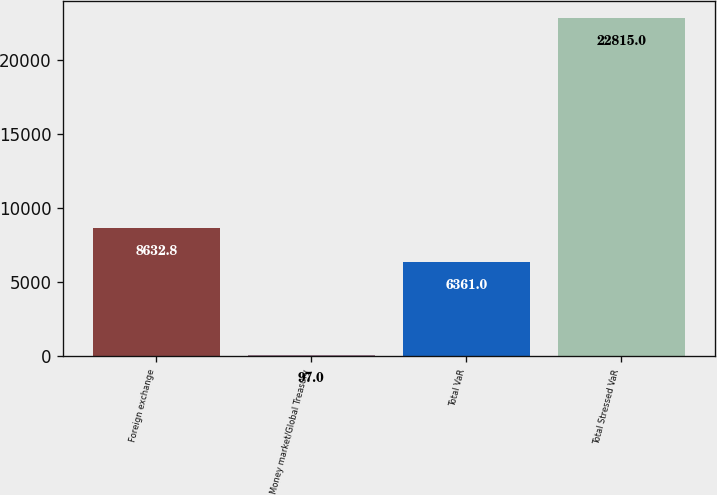Convert chart. <chart><loc_0><loc_0><loc_500><loc_500><bar_chart><fcel>Foreign exchange<fcel>Money market/Global Treasury<fcel>Total VaR<fcel>Total Stressed VaR<nl><fcel>8632.8<fcel>97<fcel>6361<fcel>22815<nl></chart> 